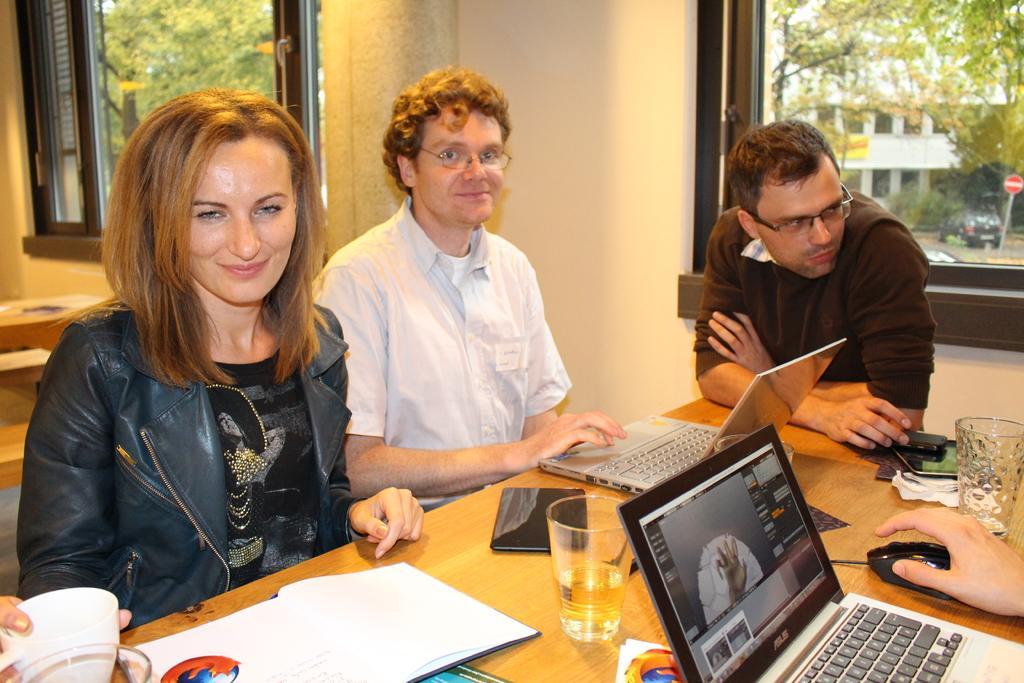How would you summarize this image in a sentence or two? This picture shows couple of men and women seated on the chair and we see a cup and a couple of glasses and couple of mobiles and a book and couple of laptops on the table and we see a human hand on the mouse and we see couple of men wore spectacles on their faces and we see trees and a building and a car parked and we see a sign board on the sidewalk from the Windows. 